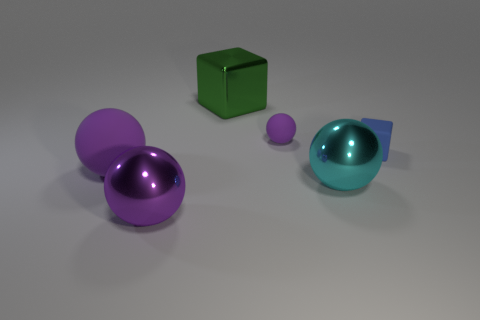Does the large rubber ball have the same color as the small matte sphere?
Your answer should be compact. Yes. What size is the other rubber ball that is the same color as the small rubber ball?
Provide a succinct answer. Large. How many big objects are yellow metallic blocks or blue cubes?
Ensure brevity in your answer.  0. Is there any other thing of the same color as the big block?
Offer a terse response. No. What is the big ball that is to the right of the small rubber object behind the cube that is on the right side of the big green metallic block made of?
Keep it short and to the point. Metal. How many matte things are either blue spheres or spheres?
Your answer should be compact. 2. What number of yellow objects are either big matte things or rubber objects?
Your response must be concise. 0. There is a rubber sphere that is left of the metal block; is it the same color as the tiny sphere?
Ensure brevity in your answer.  Yes. Does the green cube have the same material as the tiny ball?
Your response must be concise. No. Are there the same number of cyan shiny things that are to the left of the big cyan ball and purple objects that are on the right side of the matte block?
Your answer should be very brief. Yes. 